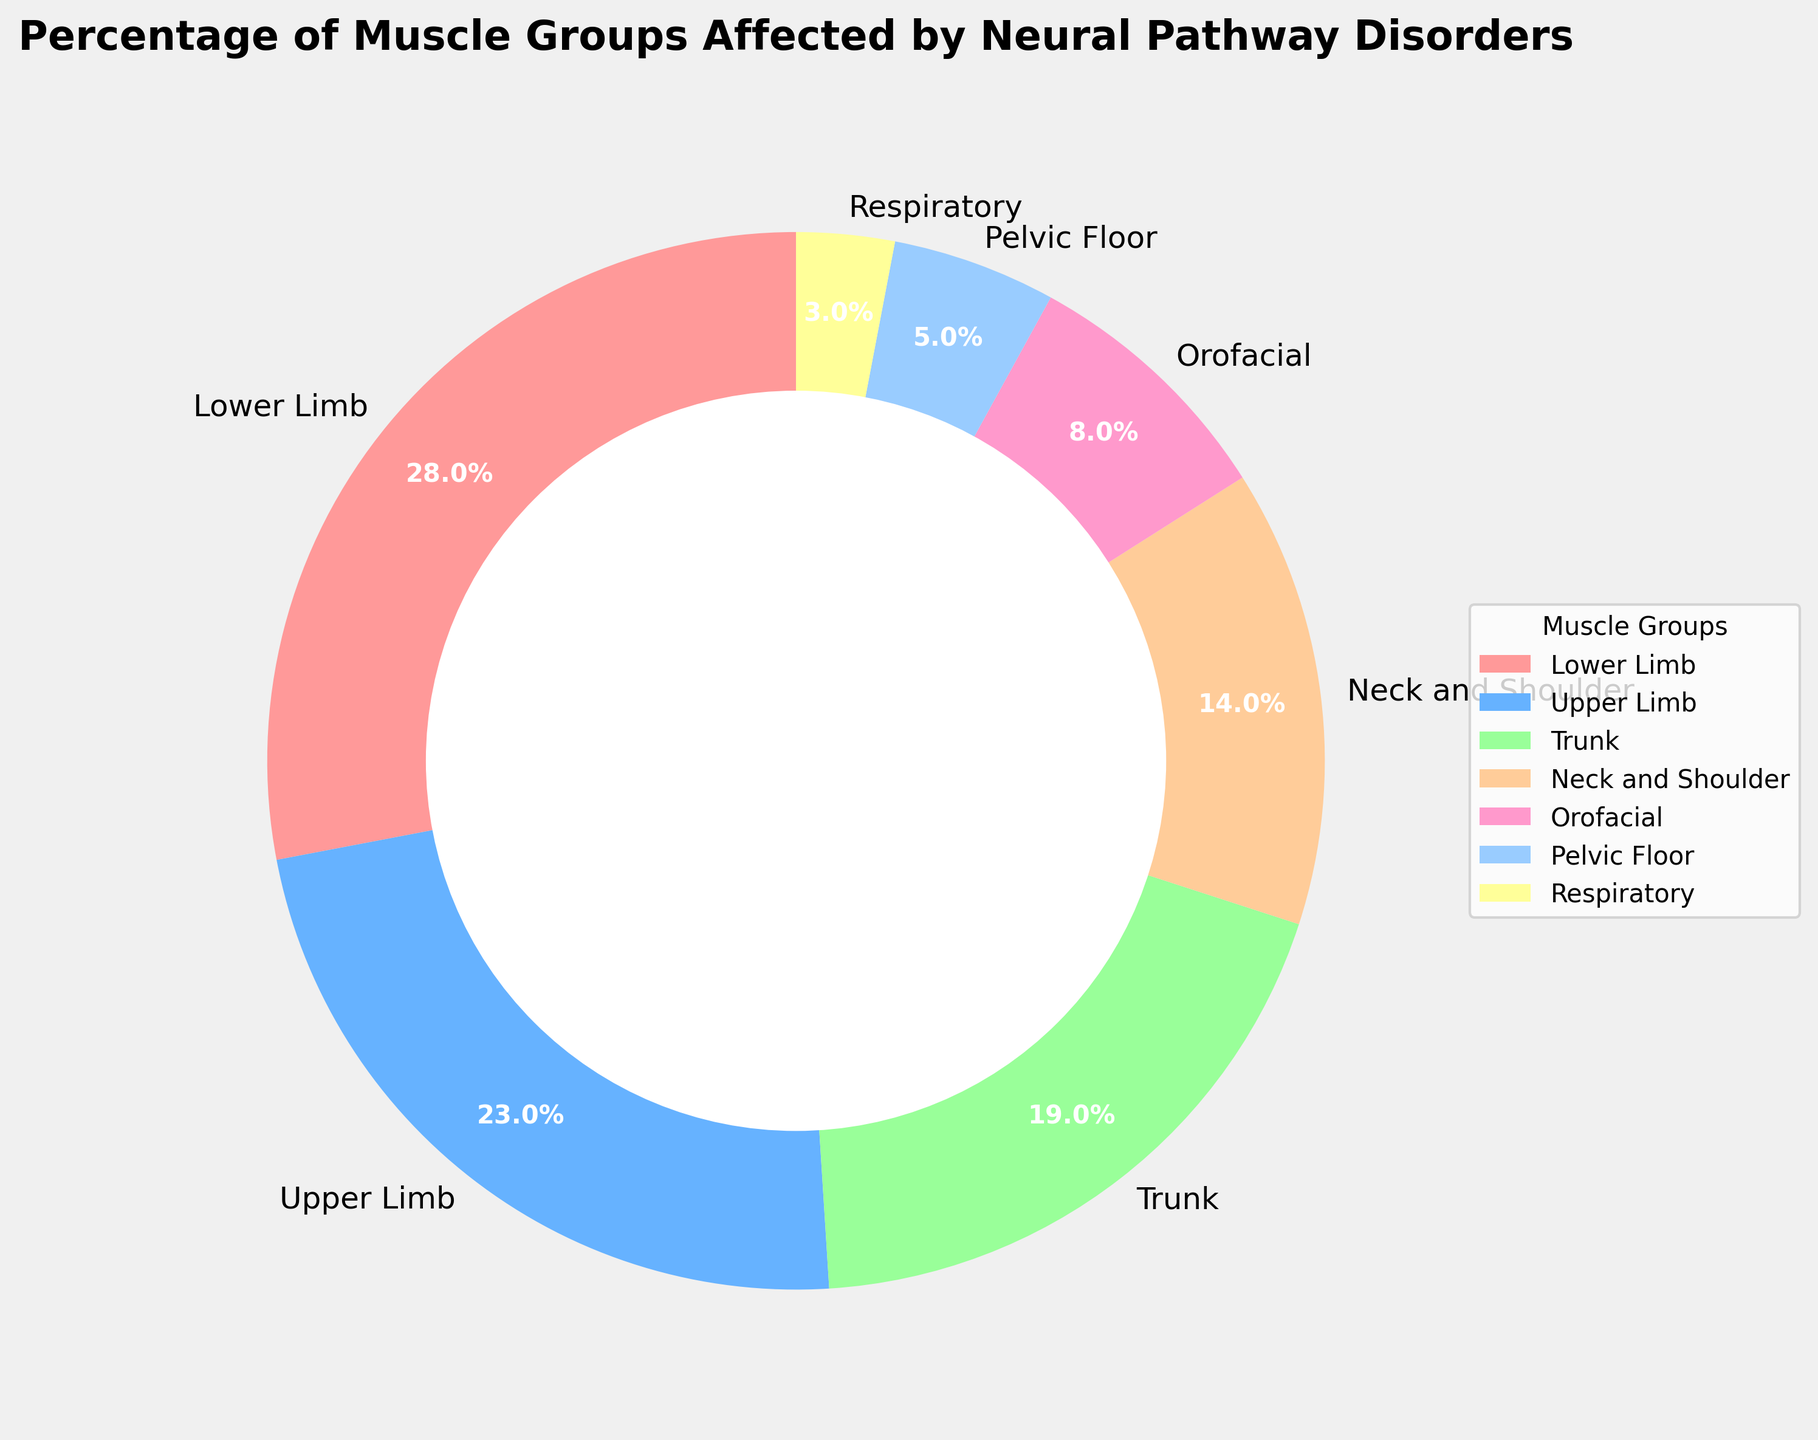what percentage of the chart is made up by the Lower Limb and Upper Limb muscle groups combined? The percentages for the Lower Limb and Upper Limb are 28% and 23%, respectively. Adding them together gives 28% + 23% = 51%.
Answer: 51% Which muscle group has the lowest percentage affected by neural pathway disorders? The muscle group with the lowest percentage is the Respiratory muscle group, which has a percentage of 3%.
Answer: Respiratory Is the percentage of the Trunk muscle group greater than the combined percentage of the Pelvic Floor and Respiratory muscle groups? The Trunk muscle group has a percentage of 19%. The combined percentage of the Pelvic Floor and Respiratory muscle groups is 5% + 3% = 8%. Since 19% is greater than 8%, the Trunk muscle group has a greater percentage.
Answer: Yes What is the difference in percentage between the Neck and Shoulder and Orofacial muscle groups? The percentage for the Neck and Shoulder muscle group is 14%, and for the Orofacial muscle group, it is 8%. The difference is 14% - 8% = 6%.
Answer: 6% By how much is the Lower Limb percentage larger than the Respiratory percentage? The percentage for the Lower Limb is 28%, and for the Respiratory muscle group, it is 3%. The difference is 28% - 3% = 25%.
Answer: 25% Which muscle group has the closest percentage value to the average percentage across all muscle groups? To find the average percentage, add the percentages of all muscle groups and divide by the number of muscle groups: (28 + 23 + 19 + 14 + 8 + 5 + 3) / 7 ≈ 100 / 7 ≈ 14.3%. The percentage closest to 14.3% is Neck and Shoulder with 14%.
Answer: Neck and Shoulder Compare the percentages of the Neck and Shoulder and Pelvic Floor muscle groups. Which one is higher? The Neck and Shoulder percentage is 14%, while the Pelvic Floor percentage is 5%. Since 14% is greater than 5%, the Neck and Shoulder percentage is higher.
Answer: Neck and Shoulder 